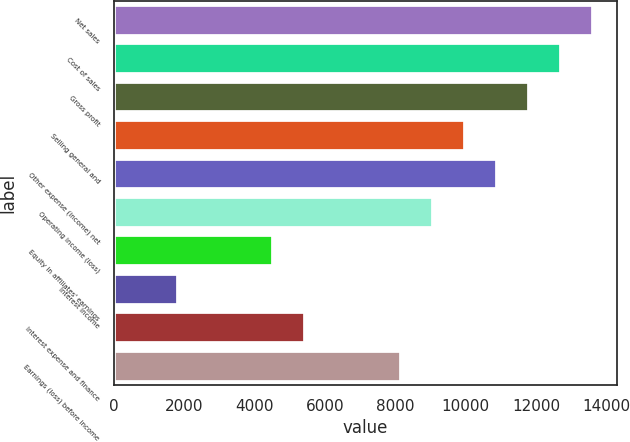<chart> <loc_0><loc_0><loc_500><loc_500><bar_chart><fcel>Net sales<fcel>Cost of sales<fcel>Gross profit<fcel>Selling general and<fcel>Other expense (income) net<fcel>Operating income (loss)<fcel>Equity in affiliates' earnings<fcel>Interest income<fcel>Interest expense and finance<fcel>Earnings (loss) before income<nl><fcel>13606.2<fcel>12699.2<fcel>11792.1<fcel>9978.03<fcel>10885.1<fcel>9070.99<fcel>4535.78<fcel>1814.64<fcel>5442.82<fcel>8163.94<nl></chart> 